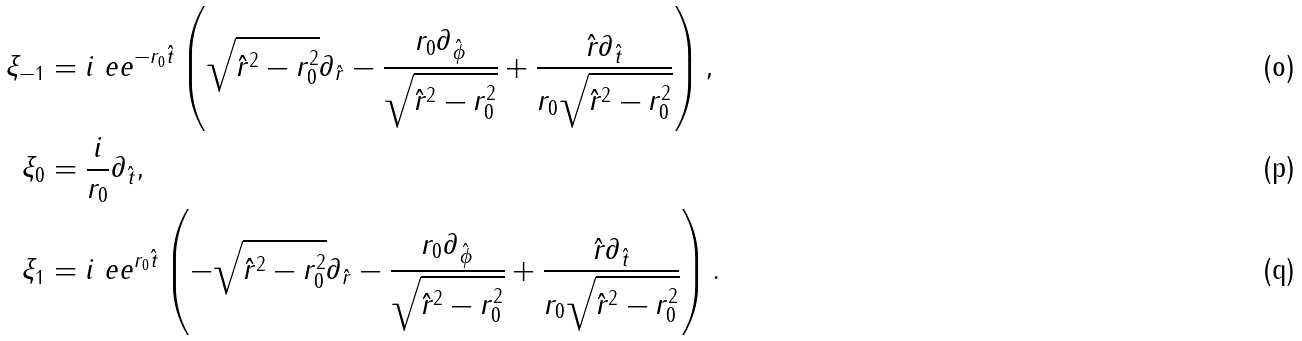Convert formula to latex. <formula><loc_0><loc_0><loc_500><loc_500>\xi _ { - 1 } & = i \ e e ^ { - r _ { 0 } \hat { t } } \left ( \sqrt { \hat { r } ^ { 2 } - r _ { 0 } ^ { 2 } } \partial _ { \hat { r } } - \frac { r _ { 0 } \partial _ { \hat { \phi } } } { \sqrt { \hat { r } ^ { 2 } - r _ { 0 } ^ { 2 } } } + \frac { \hat { r } \partial _ { \hat { t } } } { r _ { 0 } \sqrt { \hat { r } ^ { 2 } - r _ { 0 } ^ { 2 } } } \right ) , \\ \xi _ { 0 } & = \frac { i } { r _ { 0 } } \partial _ { \hat { t } } , \\ \xi _ { 1 } & = i \ e e ^ { r _ { 0 } \hat { t } } \left ( - \sqrt { \hat { r } ^ { 2 } - r _ { 0 } ^ { 2 } } \partial _ { \hat { r } } - \frac { r _ { 0 } \partial _ { \hat { \phi } } } { \sqrt { \hat { r } ^ { 2 } - r _ { 0 } ^ { 2 } } } + \frac { \hat { r } \partial _ { \hat { t } } } { r _ { 0 } \sqrt { \hat { r } ^ { 2 } - r _ { 0 } ^ { 2 } } } \right ) .</formula> 